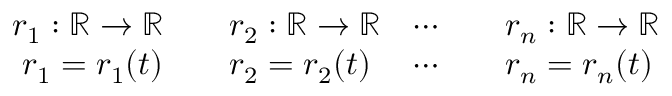Convert formula to latex. <formula><loc_0><loc_0><loc_500><loc_500>{ \begin{array} { r l r l } { r _ { 1 } \colon \mathbb { R } \rightarrow \mathbb { R } } & { \quad r _ { 2 } \colon \mathbb { R } \rightarrow \mathbb { R } } & { \cdots } & { \quad r _ { n } \colon \mathbb { R } \rightarrow \mathbb { R } } \\ { r _ { 1 } = r _ { 1 } ( t ) } & { \quad r _ { 2 } = r _ { 2 } ( t ) } & { \cdots } & { \quad r _ { n } = r _ { n } ( t ) } \end{array} }</formula> 